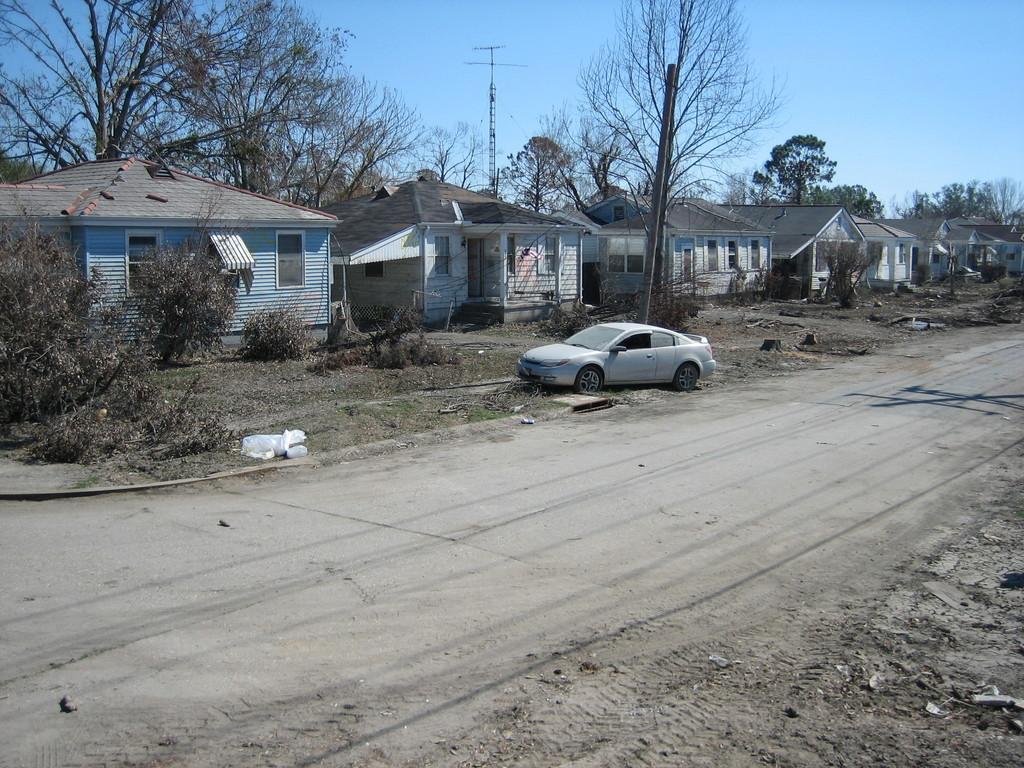Could you give a brief overview of what you see in this image? In this picture, we can see a few houses, trees, plants, vehicle, ground, and some objects on the ground, poles, and the sky. 